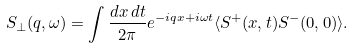<formula> <loc_0><loc_0><loc_500><loc_500>S _ { \perp } ( q , \omega ) = \int \frac { d x \, d t } { 2 \pi } e ^ { - i q x + i \omega t } \langle S ^ { + } ( x , t ) S ^ { - } ( 0 , 0 ) \rangle .</formula> 